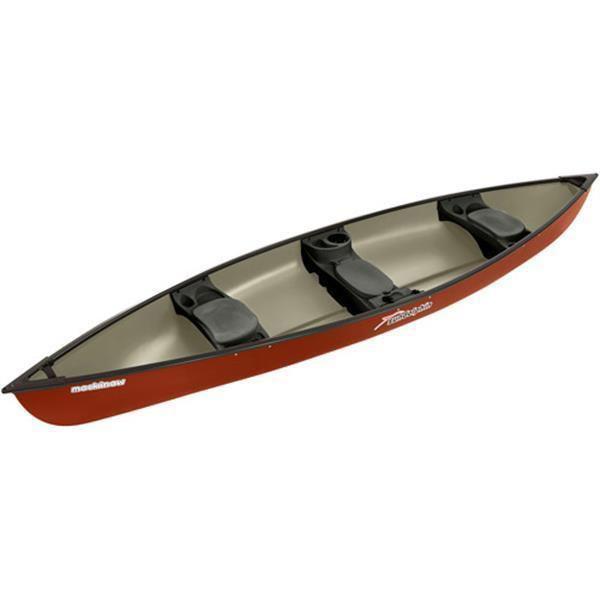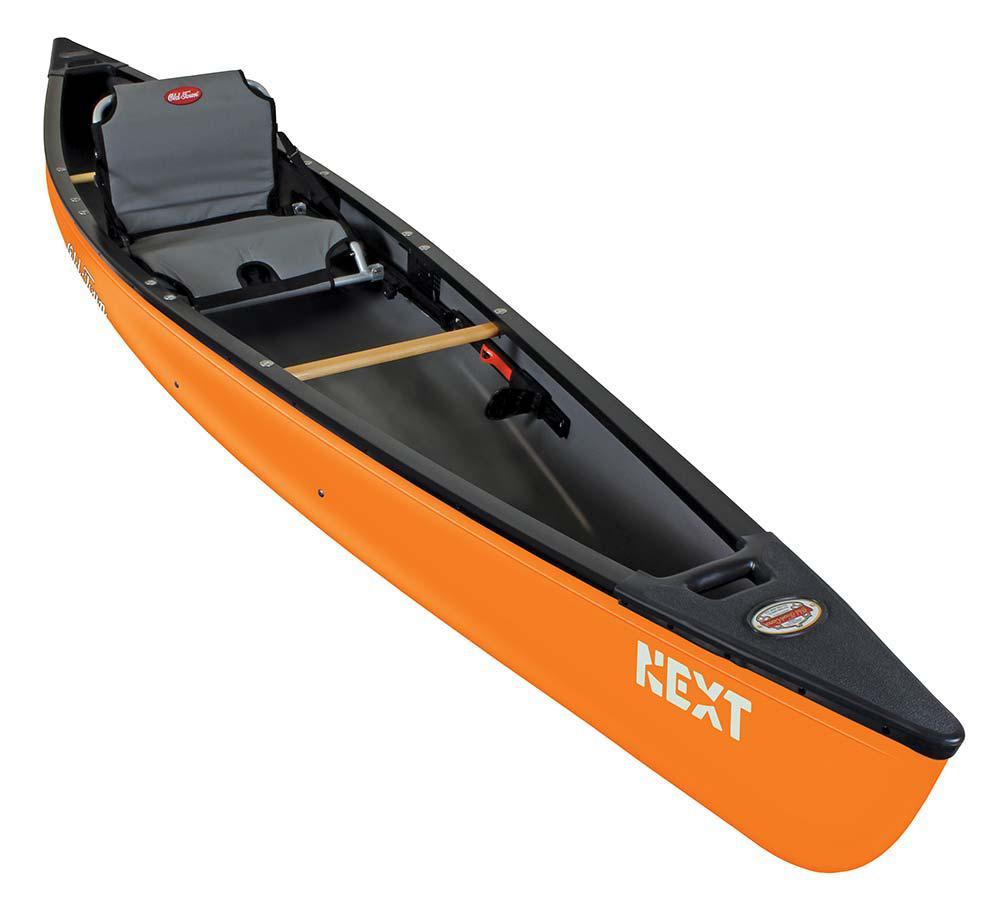The first image is the image on the left, the second image is the image on the right. Considering the images on both sides, is "the right side pic has a boat with seats that have back rests" valid? Answer yes or no. Yes. The first image is the image on the left, the second image is the image on the right. For the images shown, is this caption "there are 6 seats in the canoe  in the image pair" true? Answer yes or no. No. 